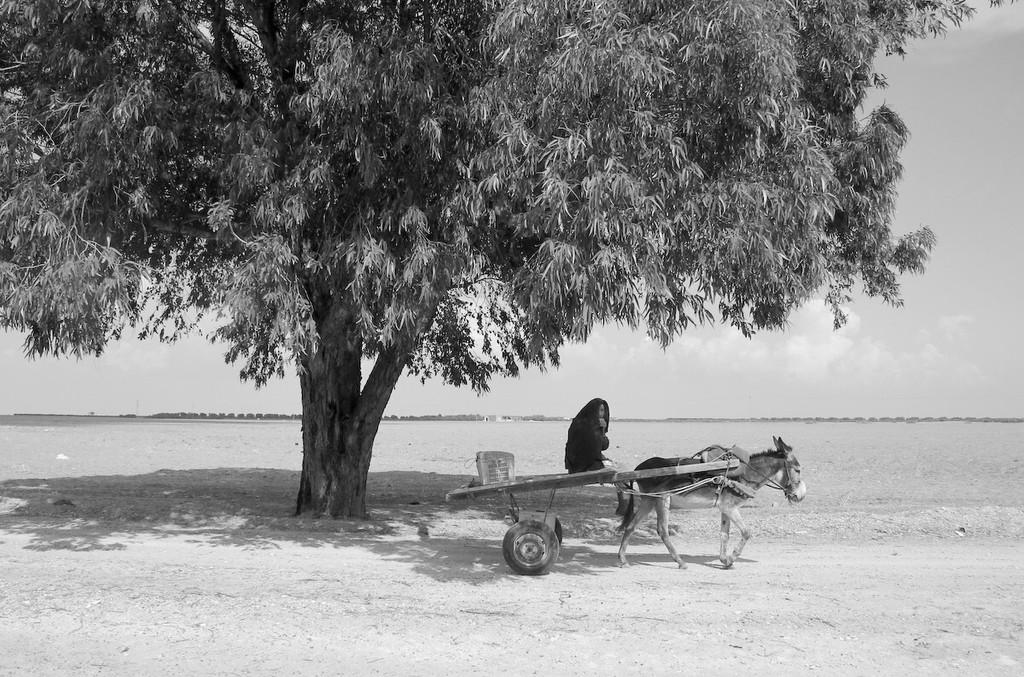What is the person in the image sitting on? The person is sitting on a cart. What is pulling the cart in the image? The cart is being pulled by a donkey. Can you describe any vegetation in the image? There is a tree in the image, and trees are visible in the background. What can be seen in the sky in the image? The sky is clear in the background of the image. What type of fuel is being used to power the donkey in the image? The donkey is not powered by fuel; it is a living animal that is pulling the cart. What kind of breakfast is the person eating while sitting on the cart? There is no indication in the image that the person is eating breakfast or any other food. 